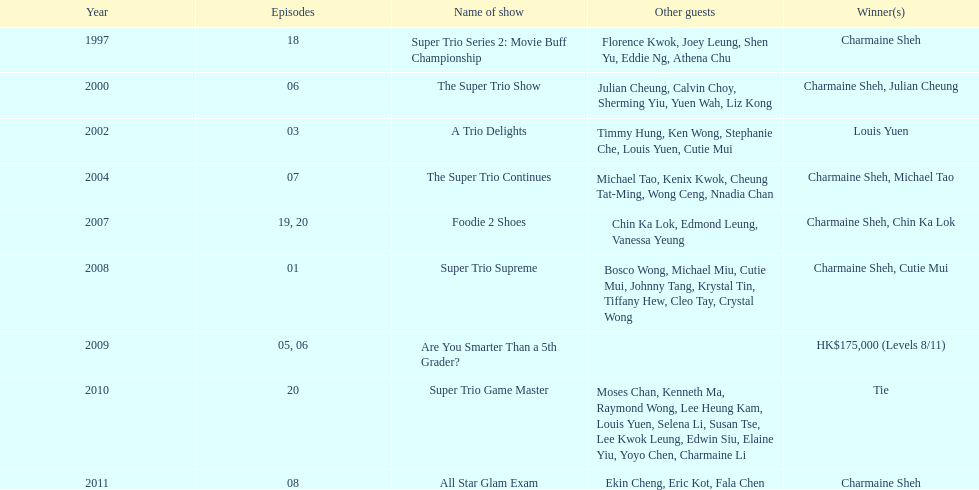How many episodes was charmaine sheh on in the variety show super trio 2: movie buff champions 18. 